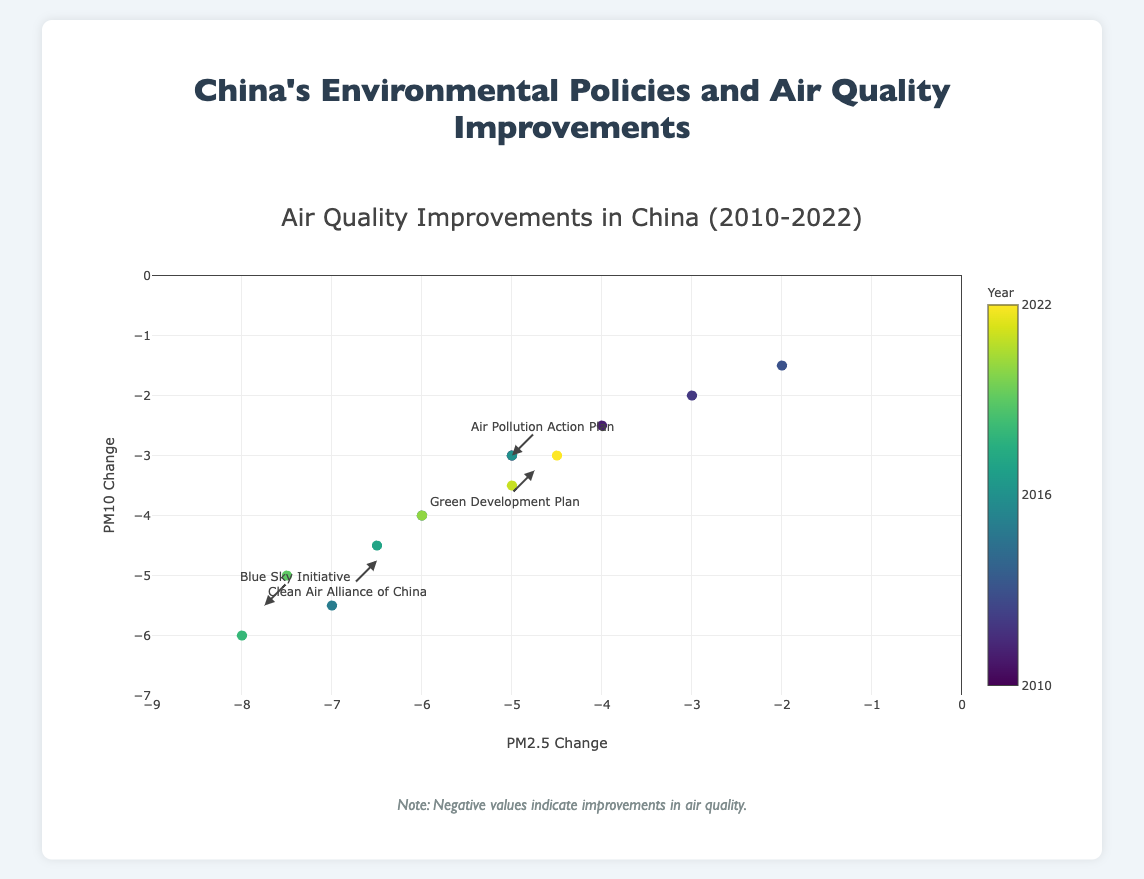What is the title of the figure? The title is generally positioned at the top of the figure and provides an overall description. The title reads "Air Quality Improvements in China (2010-2022)"
Answer: Air Quality Improvements in China (2010-2022) What does a negative value indicate in this visualization? The note beneath the plot states that negative values indicate improvements in air quality. Thus, both PM2.5 and PM10 changes in negative values signify improved air quality.
Answer: Improvements in air quality Which policy is associated with the largest improvement in PM2.5 levels? By observing the data points and the annotations, the Blue Sky Initiative, particularly in 2018, shows the largest improvement in PM2.5 levels with a value of -8.0.
Answer: Blue Sky Initiative Between 2012 and 2014, which year had the smallest improvement in PM2.5 levels? Within this period, the improvements are noted as -3.0 (2012), -2.0 (2013), and -6.0 (2014). The year 2013 sees the smallest improvement in PM2.5 levels at -2.0.
Answer: 2013 What is the average PM10 change for the Blue Sky Initiative policy? The PM10 changes for the Blue Sky Initiative are -6.0, -5.0, and -4.0. Summing these gives -15.0, and the average is -15.0/3 = -5.0
Answer: -5.0 How many different policies are depicted in this figure? Reviewing the annotations on the figure, there are five distinct policies: Air Pollution Action Plan, Clean Air Alliance of China, Clean Air Action Plan, Blue Sky Initiative, and Green Development Plan.
Answer: Five Which year shows the maximum improvement for both PM2.5 and PM10 levels? Looking at the vertical alignment of data points, the year 2018 corresponding to the Blue Sky Initiative shows the highest improvement values of -8.0 for PM2.5 and -6.0 for PM10.
Answer: 2018 Does the Air Pollution Action Plan tend to have a higher or lower impact on air quality compared to the Blue Sky Initiative? Comparing data points, the Air Pollution Action Plan generally has lower magnitude improvements for both PM2.5 and PM10 than the Blue Sky Initiative, which has the highest values.
Answer: Lower impact What is the range of years covered by the policies in the figure? The earliest year in the plot is 2010, while the latest year is 2022, therefore covering a range from 2010 to 2022.
Answer: 2010 to 2022 